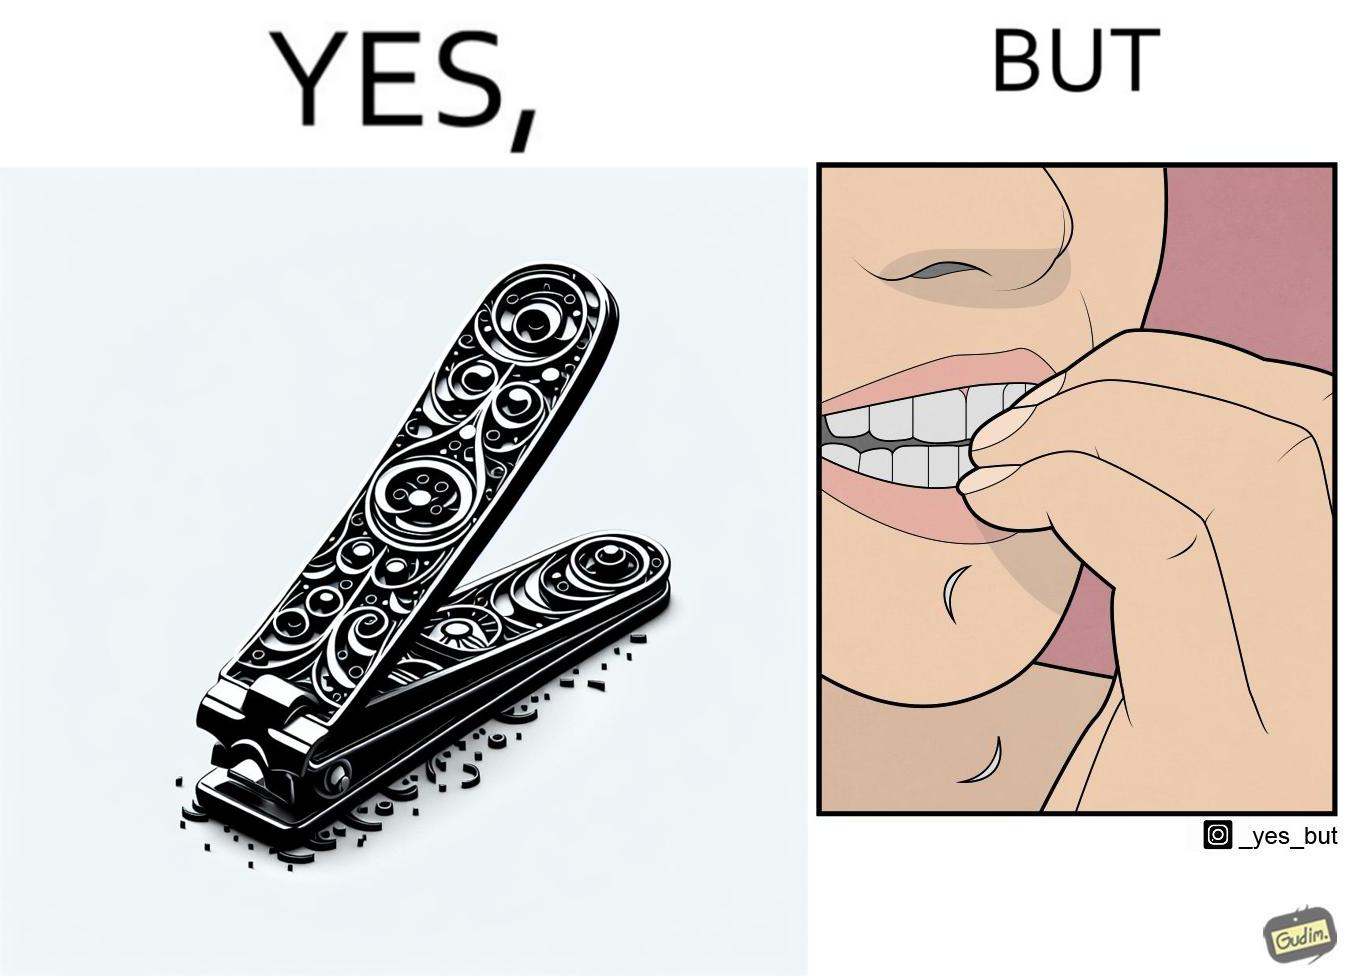Describe the satirical element in this image. The image is ironic, because even after nail clippers are available people prefer biting their nails by teeth 